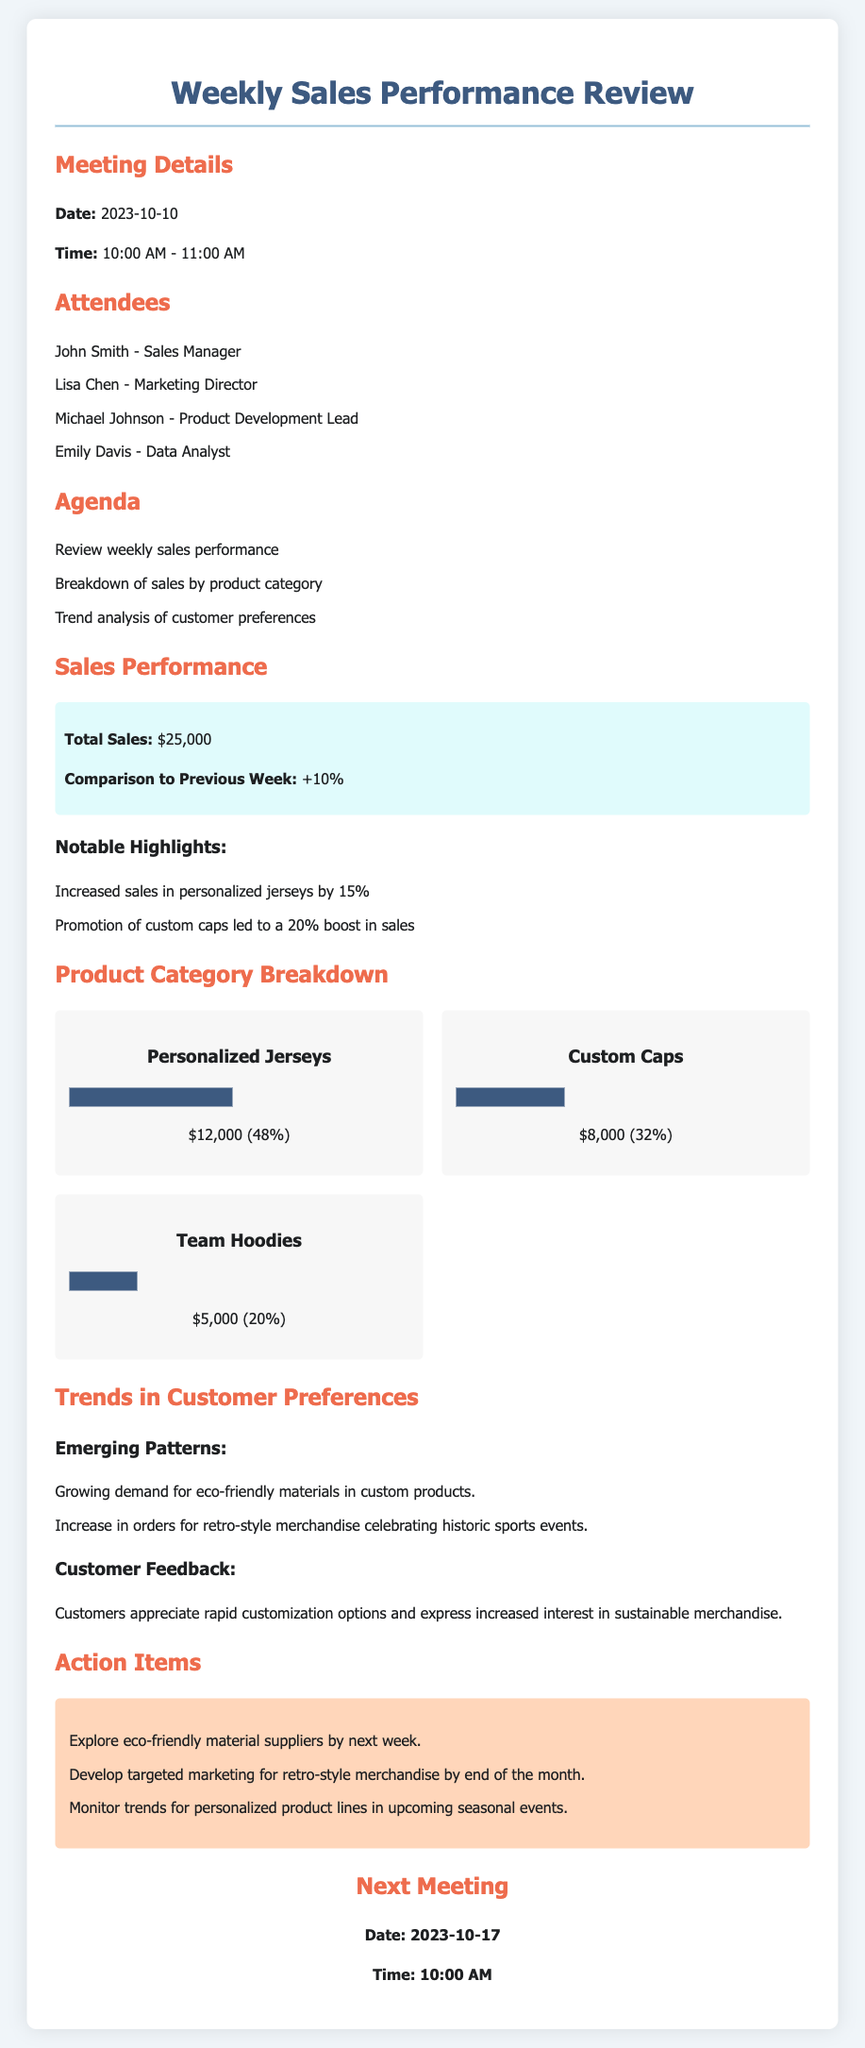What was the total sales amount for the week? The total sales amount is provided in the document under the sales performance section.
Answer: $25,000 What is the percentage increase in sales compared to the previous week? The percentage increase in sales is mentioned as a comparison in the sales performance section.
Answer: +10% Which product category had the highest sales? The product category with the highest sales is indicated in the product category breakdown section.
Answer: Personalized Jerseys What was the sales amount for custom caps? The sales amount for custom caps is listed in the product category breakdown section.
Answer: $8,000 What are the emerging patterns in customer preferences? The emerging patterns in customer preferences are highlighted in the trends section of the document.
Answer: Growing demand for eco-friendly materials in custom products What is one action item regarding eco-friendly materials? The action item related to eco-friendly materials is specified in the action items section of the document.
Answer: Explore eco-friendly material suppliers by next week What date is the next meeting scheduled for? The date for the next meeting is provided at the bottom of the document.
Answer: 2023-10-17 Who is the Sales Manager attending the meeting? The name of the Sales Manager is listed in the attendees section.
Answer: John Smith What percentage of total sales do team hoodies represent? The percentage for team hoodies is specified in the product category breakdown section.
Answer: 20% What marketing strategy is to be developed by the end of the month? The marketing strategy mentioned is related to retro-style merchandise in the action items section.
Answer: Targeted marketing for retro-style merchandise by end of the month 